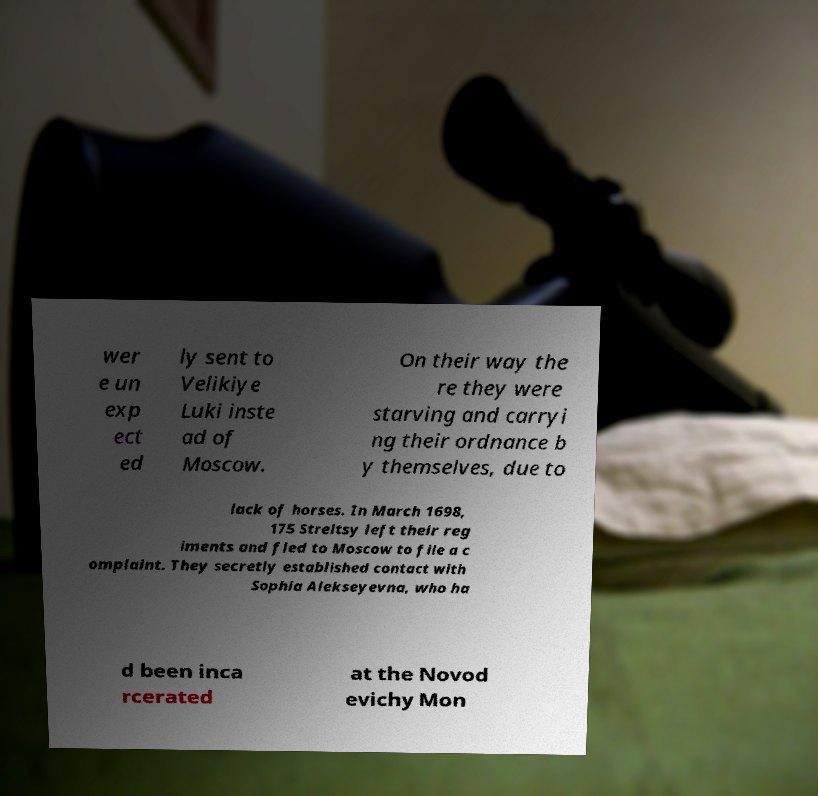Please identify and transcribe the text found in this image. wer e un exp ect ed ly sent to Velikiye Luki inste ad of Moscow. On their way the re they were starving and carryi ng their ordnance b y themselves, due to lack of horses. In March 1698, 175 Streltsy left their reg iments and fled to Moscow to file a c omplaint. They secretly established contact with Sophia Alekseyevna, who ha d been inca rcerated at the Novod evichy Mon 